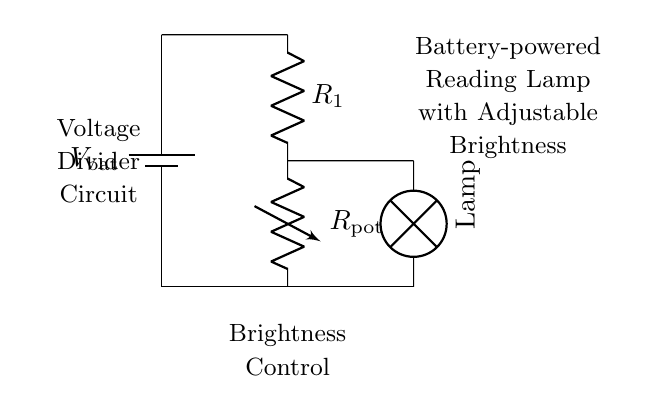What is the purpose of the variable resistor? The variable resistor, labeled as R pot, is used to adjust the brightness of the reading lamp by varying the resistance in the circuit, which in turn influences the voltage drop across the lamp.
Answer: Adjust brightness What type of circuit is this? This is a voltage divider circuit, as it uses a combination of resistors to divide the input voltage and control the output voltage to the lamp.
Answer: Voltage divider What component connects directly to the battery? The battery connects to R1 directly. The positive terminal of the battery is connected to the top of R1, completing the circuit.
Answer: Resistor one How many resistors are in the circuit? There are two resistors in the circuit: one fixed resistor (R1) and one variable resistor (R pot).
Answer: Two What happens to the lamp's brightness when R pot is increased? When R pot is increased, the resistance increases, which generally decreases the voltage across the lamp, resulting in dimmer light.
Answer: Dims What is the function of the lamp? The function of the lamp is to provide light for reading, which is powered by the adjusted voltage from the divider circuit.
Answer: Provide light What does the voltage divider achieve in this circuit? The voltage divider reduces the voltage from the battery to a suitable level for the lamp to operate while allowing for brightness adjustment.
Answer: Adjusts voltage 